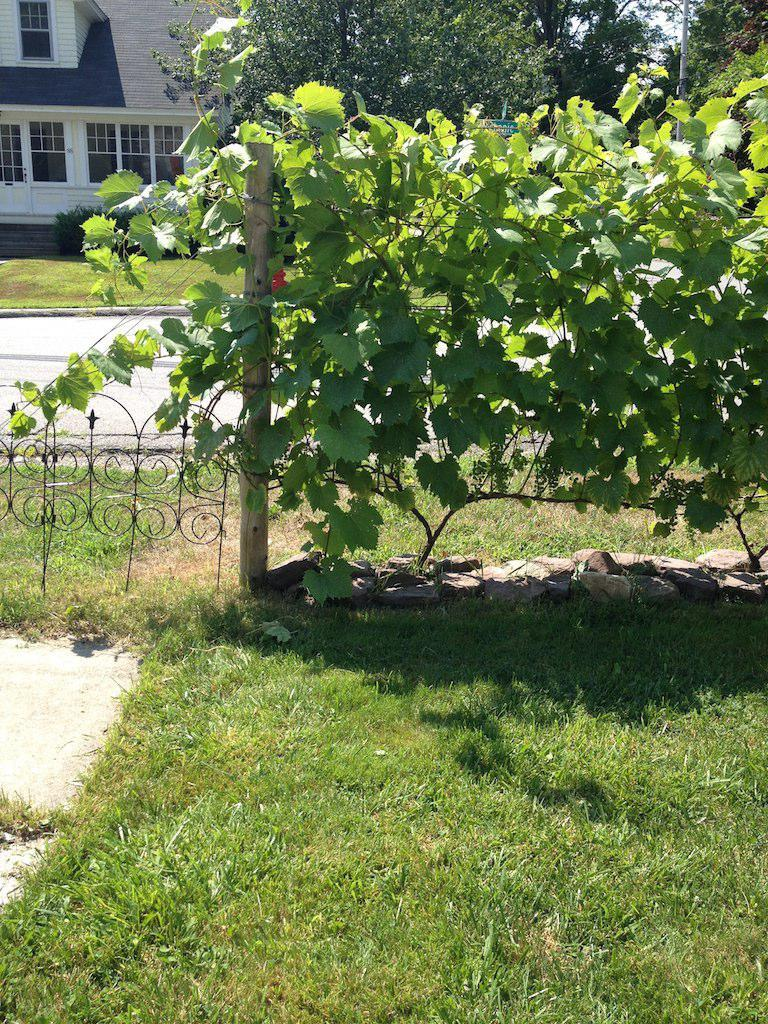What type of structure is visible in the image? There is a building in the image. What type of barrier is present in the image? There is a fence in the image. What type of natural elements can be seen in the image? There are stones, plants, grass, and trees in the image. What type of vertical structure is present in the image? There is a pole in the image. What type of architectural feature is present in the image? There are stairs in the image. What type of pathway is visible in the image? There is a road in the image. How many men are using a hammer in the image? There are no men or hammers present in the image. What type of care is being provided to the plants in the image? There is no indication of care being provided to the plants in the image. 